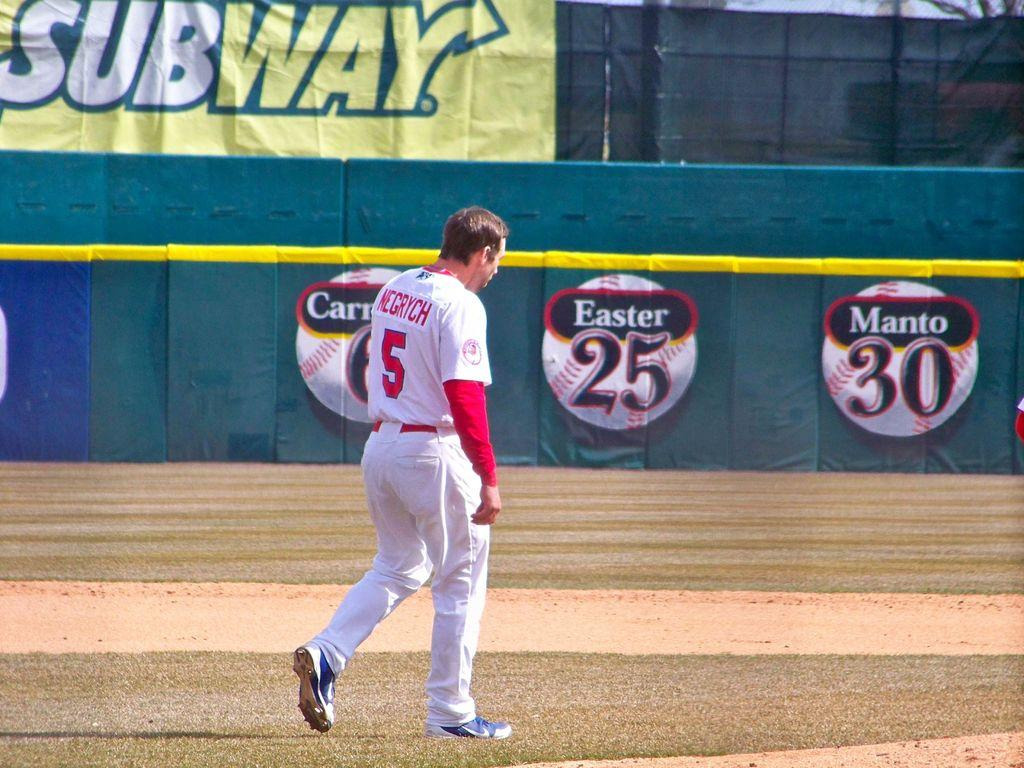What is the person in the image doing? There is a person walking in the image. What surface is the person walking on? The person is walking on the ground. What can be seen on the boundary fence in the image? There are banners on the boundary fence in the image. What information is displayed on the banners? The banners have sponsor names on them. How many stitches are visible on the person's clothing in the image? There is no information about the person's clothing or the number of stitches in the image. --- Facts: 1. There is a person sitting on a chair in the image. 2. The person is holding a book. 3. The book has a title on the cover. 4. There is a table next to the chair. 5. The table has a lamp on it. Absurd Topics: dance, ocean, bird Conversation: What is the person in the image doing? There is a person sitting on a chair in the image. What is the person holding in the image? The person is holding a book. What can be seen on the cover of the book? The book has a title on the cover. What is located next to the chair in the image? There is a table next to the chair. What object is on the table in the image? The table has a lamp on it. Reasoning: Let's think step by step in order to produce the conversation. We start by identifying the main subject in the image, which is the person sitting on a chair. Then, we expand the conversation to include details about the person's actions and the objects they are interacting with, such as the book they are holding and the table and lamp next to the chair. Each question is designed to elicit a specific detail about the image that is known from the provided facts. Absurd Question/Answer: Can you describe the dance performance happening in the background of the image? There is no dance performance or background visible in the image; it only shows a person sitting on a chair holding a book. 